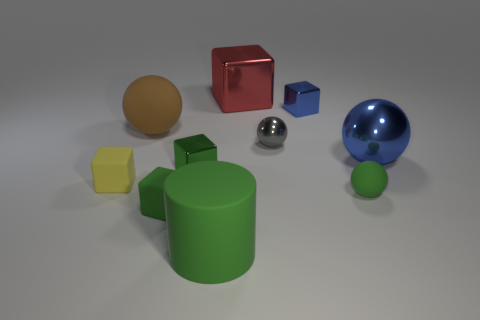What is the shape of the large metal object that is behind the tiny shiny sphere?
Keep it short and to the point. Cube. Does the large red metallic thing have the same shape as the small metallic object that is right of the small gray metallic object?
Offer a very short reply. Yes. Are there the same number of rubber things that are to the left of the gray metallic object and large balls to the right of the brown sphere?
Your answer should be compact. No. There is a large thing that is the same color as the tiny rubber sphere; what is its shape?
Keep it short and to the point. Cylinder. There is a matte sphere that is in front of the small yellow cube; is its color the same as the tiny shiny cube behind the small gray metallic ball?
Give a very brief answer. No. Is the number of green spheres behind the large shiny sphere greater than the number of tiny yellow rubber cubes?
Keep it short and to the point. No. What is the material of the big red cube?
Ensure brevity in your answer.  Metal. The big brown thing that is made of the same material as the green cylinder is what shape?
Your response must be concise. Sphere. There is a green thing that is behind the cube on the left side of the big brown rubber thing; what size is it?
Provide a succinct answer. Small. There is a rubber block behind the small rubber sphere; what color is it?
Provide a succinct answer. Yellow. 